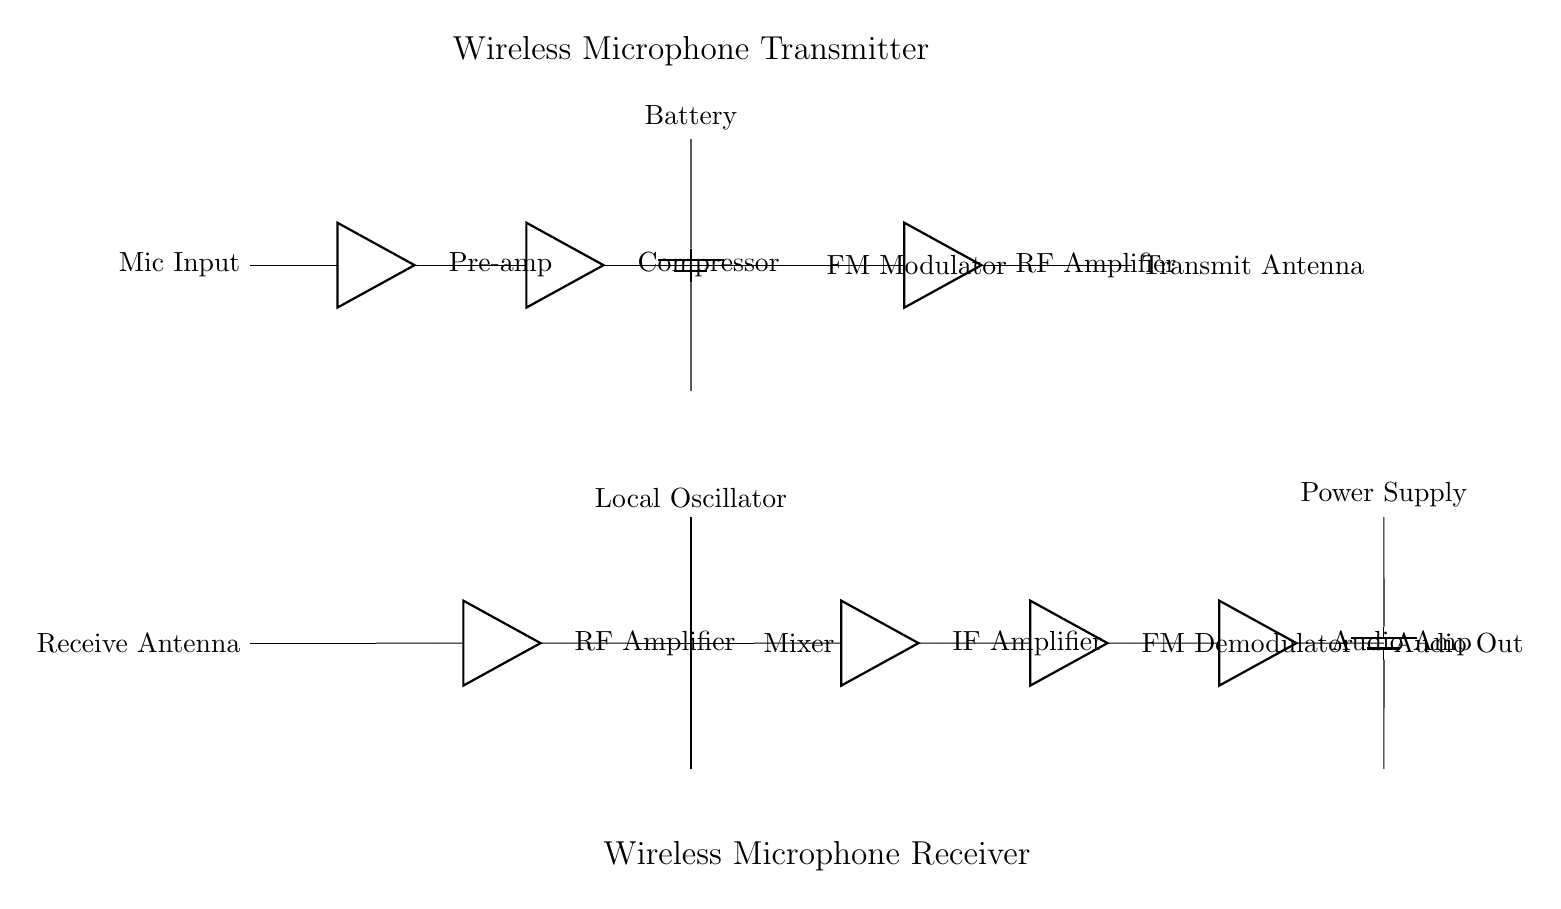What is the main purpose of the circuit? The main purpose of the circuit is to transmit audio wirelessly from a microphone to a receiver, making it suitable for live performances.
Answer: Wireless audio transmission What type of amplifier is used before the transmitter's antenna? The type of amplifier used is a radio frequency amplifier, which boosts the modulated signal before transmission.
Answer: RF Amplifier What component is responsible for modulating the audio signal? The component responsible for modulating the audio signal is the FM modulator, which encodes the audio onto a carrier wave.
Answer: FM Modulator Which component in the receiver is responsible for converting the radio frequency signals back to audio? The component responsible for converting the radio frequency signals back to audio is the FM demodulator, which extracts the audio from the RF signal.
Answer: FM Demodulator What is the power source for the transmitter? The power source for the transmitter is a battery, which provides the necessary voltage to power the components.
Answer: Battery How does the local oscillator assist in the receiving process? The local oscillator generates a frequency that mixes with the incoming RF signal in the mixer, allowing the extraction of the audio signal from the RF carrier wave.
Answer: Frequency conversion 